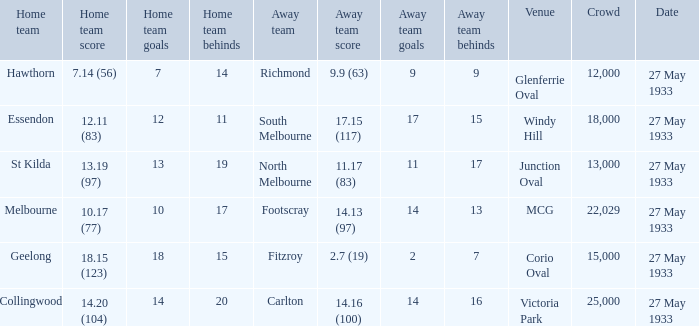In the match where the away team scored 2.7 (19), how many peopel were in the crowd? 15000.0. 